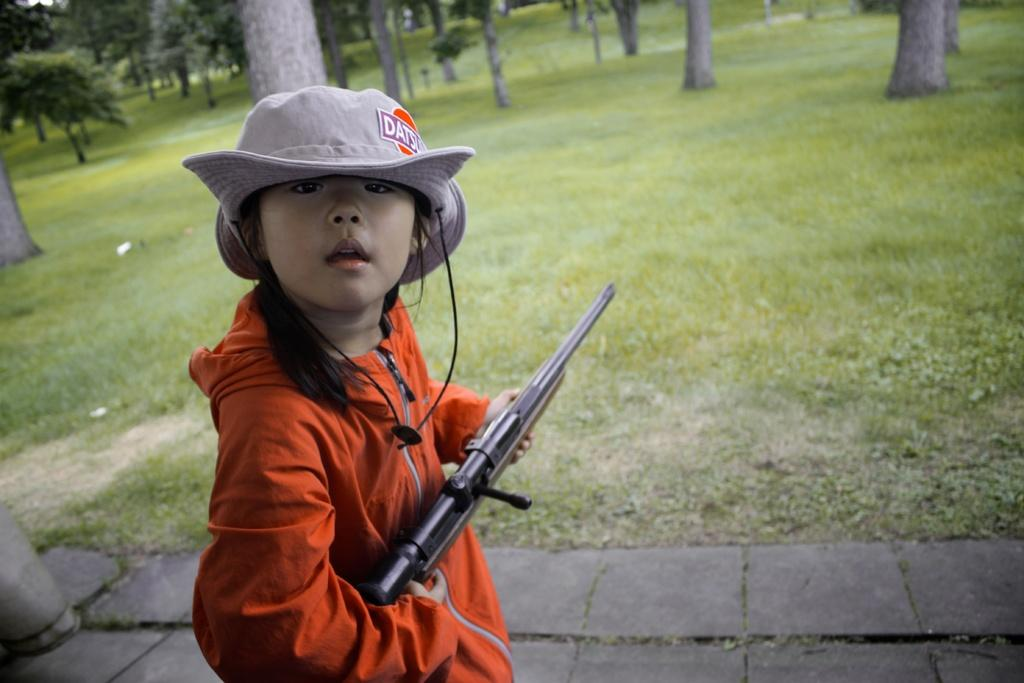Who is the main subject in the image? There is a girl in the center of the image. What is the girl doing in the image? The girl is standing and holding a gun. What can be seen in the background of the image? There are trees in the background of the image. What type of terrain is visible at the bottom of the image? There is grass at the bottom of the image. What pathway is present in the image? There is a walkway in the image. What type of oven is visible in the image? There is no oven present in the image. Can you tell me how many lawyers are standing next to the girl in the image? There are no lawyers present in the image. 